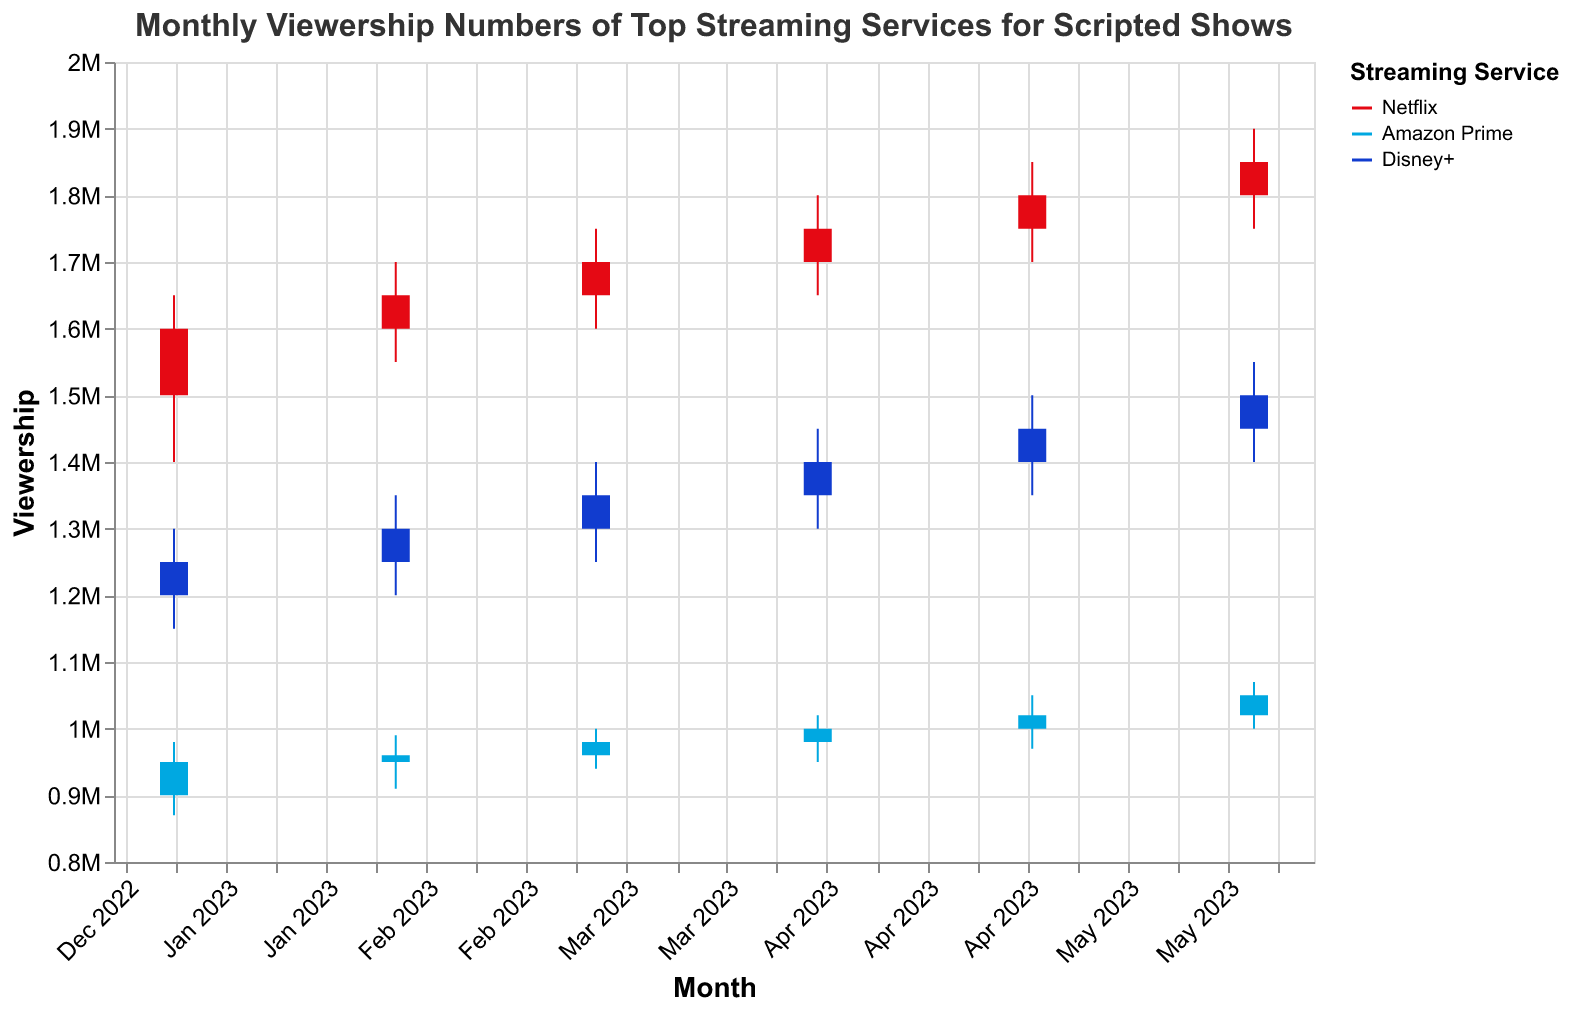When did Netflix have its highest viewership? The plot shows the high values for each month and service. Netflix reaches its highest point at 1.9 million in June 2023.
Answer: June 2023 What is the average viewership close value for Amazon Prime over the six months? We need to sum the close values for Amazon Prime from Jan to Jun (950000, 960000, 980000, 1000000, 1020000, 1050000) and divide by six. The sum is 5960000, so the average is 5960000 / 6 = 993333.
Answer: 993333 Which streaming service shows the most significant growth in viewership from January to June? Netflix's viewership increased from 1.6 million in January to 1.85 million in June. Amazon Prime's viewership increased from 950,000 in January to 1.05 million in June. Disney+ viewership increased from 1.25 million in January to 1.5 million in June. Netflix has the most significant growth.
Answer: Netflix From which month to which month did Disney+ witness the highest increase in viewership? We compare the close values of Disney+ between adjacent months and see that the highest jump is from April to May with values increasing from 1.4 million to 1.45 million.
Answer: April to May By how much did Netflix's viewership grow in February 2023 compared to January 2023? The close value for Netflix in January was 1.6 million and in February it was 1.65 million. The growth is 1.65 million - 1.6 million = 50,000.
Answer: 50,000 How many months did Amazon Prime have a viewership close value above 1 million? We check each month's close value for Amazon Prime. Only in May and June did it exceed 1 million, so that is 2 months.
Answer: 2 What was the lowest viewership number recorded by Disney+ and in which month? The plot shows the low values for each month and service. Disney+'s lowest point was 1.15 million in January 2023.
Answer: January 2023 Which month had the smallest variability range in viewership for any of the streaming services? We calculate the range (High - Low) for each month and service. For Amazon Prime, it's (1000000-940000)=60000 in March, which is the smallest range for any service in any month.
Answer: March 2023 Compare the opening viewership for Netflix in January 2023 and June 2023. Which month had a higher opening value and by how much? The opening value for January 2023 is 1.5 million and for June 2023 it is 1.8 million. June has a higher opening, and the difference is 1.8 million - 1.5 million = 300,000.
Answer: June by 300,000 What is the overall trend in Netflix's viewership from January to June 2023? Observing the plot, Netflix's viewership steadily increases each month from January (1.6 million) to June (1.85 million).
Answer: Increasing 